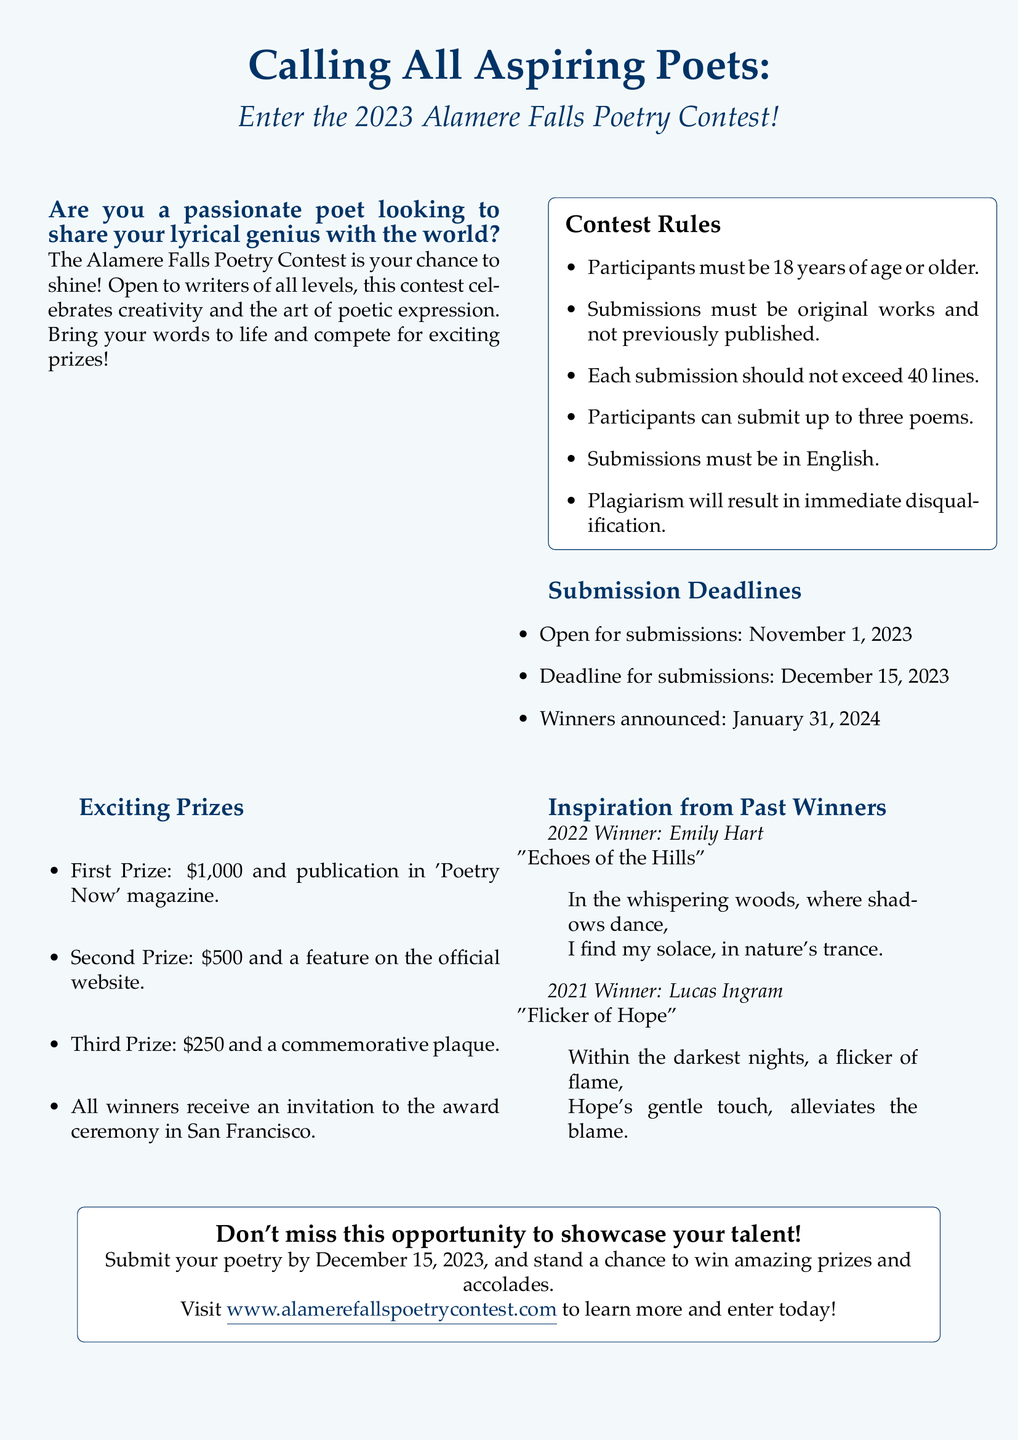What are the submission deadlines? The document lists the open date for submissions, the submission deadline, and the winners announcement date.
Answer: November 1, 2023; December 15, 2023; January 31, 2024 How many poems can participants submit? The document specifies limitations on submissions, particularly regarding the number of poems allowed per participant.
Answer: Up to three poems What is the first prize? The document outlines the prizes for each category, highlighting the first prize for the contest.
Answer: $1,000 and publication in 'Poetry Now' magazine Who was the winner in 2022? The document provides information on past winners, including their names and the titles of their winning poems.
Answer: Emily Hart What will happen to plagiarized submissions? The document clarifies the disqualifying criteria regarding submission originality and consequences for violations.
Answer: Immediate disqualification What is the theme of Lucas Ingram's winning poem? The document mentions the title of Lucas Ingram's poem, which can help infer its theme or focus.
Answer: Flicker of Hope Where will the award ceremony be held? The document indicates the location of the award ceremony for contest winners.
Answer: San Francisco 